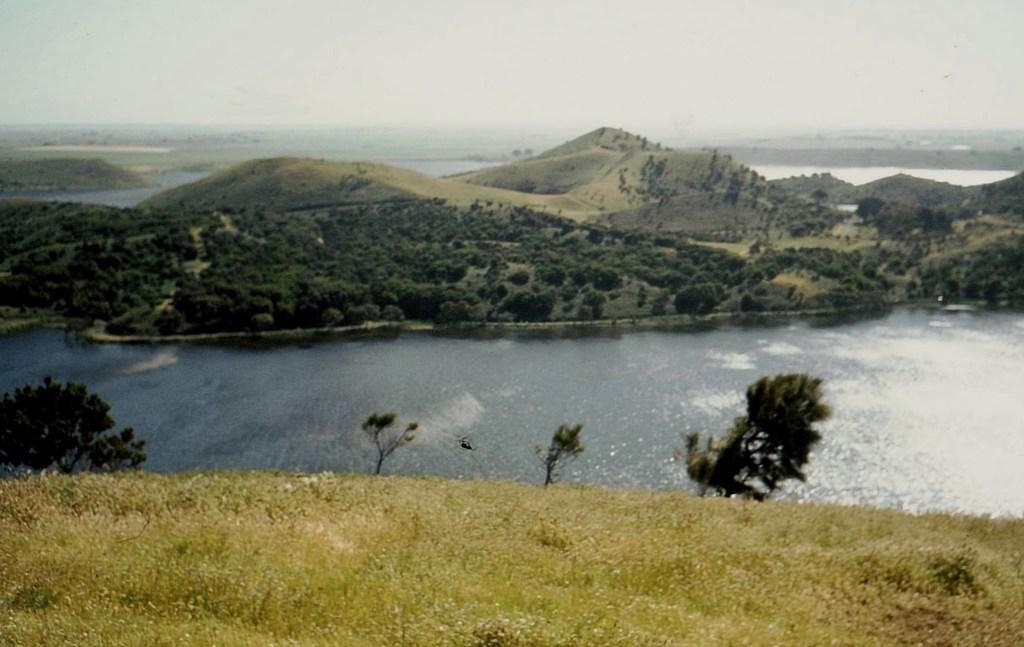What type of vegetation is present in the image? There is grass in the image. What is the color of the grass? The grass is green. What other natural elements can be seen in the image? There are trees in the image. What is the color of the trees? The trees are green. What can be seen in the background of the image? Water is visible in the background of the image. What is the color of the sky in the image? The sky is white in color. How many planes are flying over the trees in the image? There are no planes visible in the image; it only features grass, trees, water, and a white sky. What type of sack is hanging from the tree in the image? There is no sack present in the image; it only features grass, trees, water, and a white sky. 